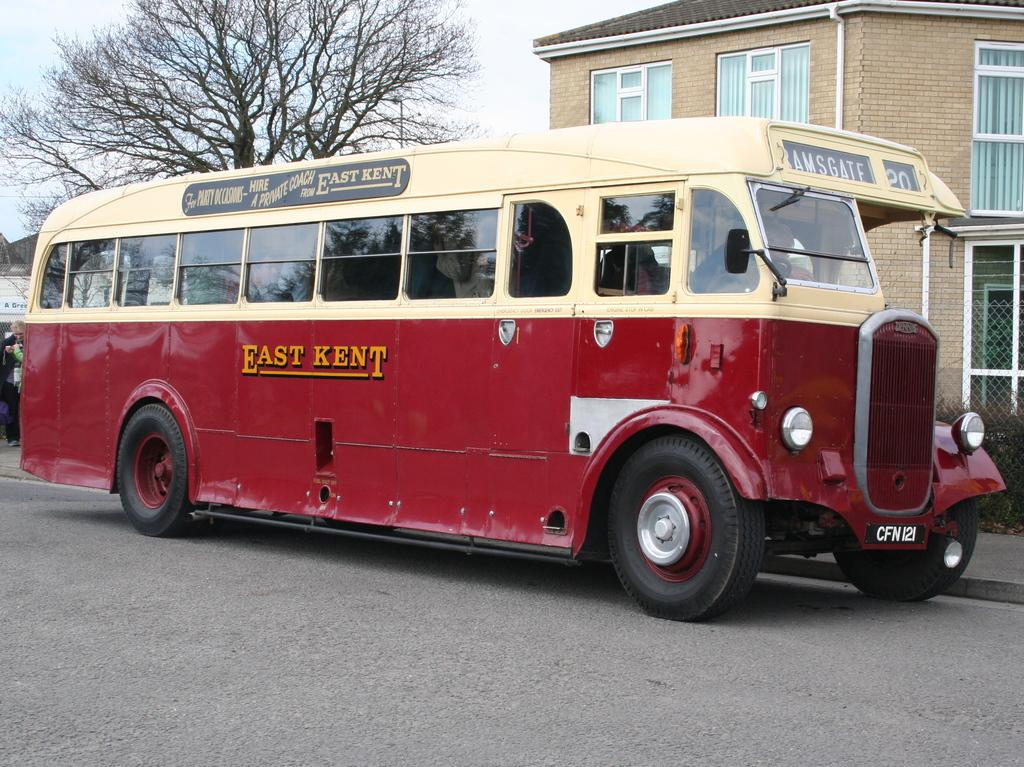What type of vehicle is in the image? There is a red bus in the image. What is at the bottom of the image? There is a road at the bottom of the image. What can be seen in the background of the image? There is a building and a tree in the background of the image. How many horses are pulling the red bus in the image? There are no horses present in the image; the red bus is a motorized vehicle. What color is the wristband on the tree in the image? There is no wristband on the tree in the image; it is a natural element with no human-made accessories. 